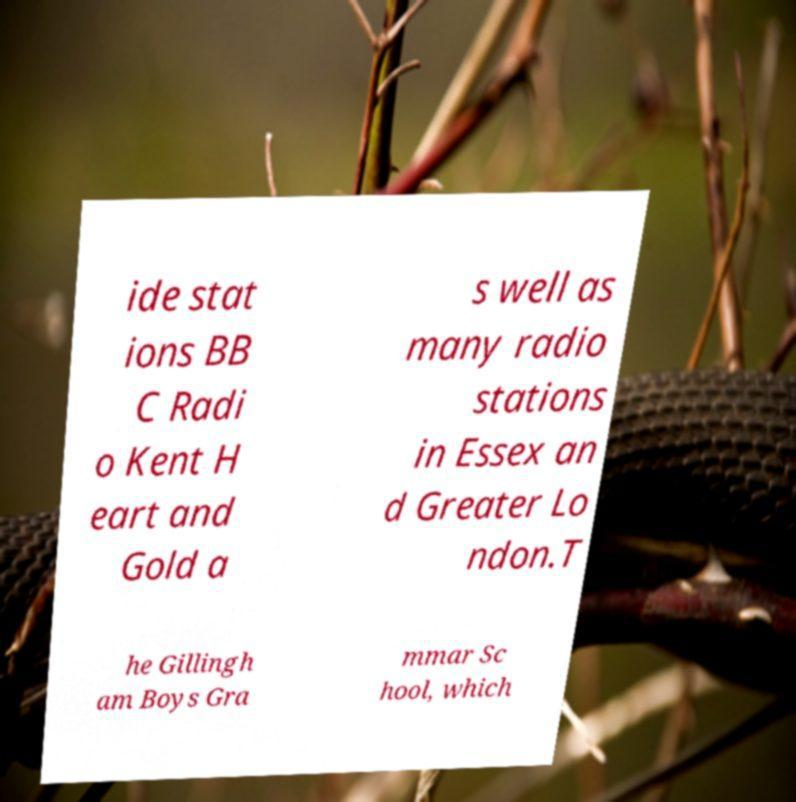Please read and relay the text visible in this image. What does it say? ide stat ions BB C Radi o Kent H eart and Gold a s well as many radio stations in Essex an d Greater Lo ndon.T he Gillingh am Boys Gra mmar Sc hool, which 